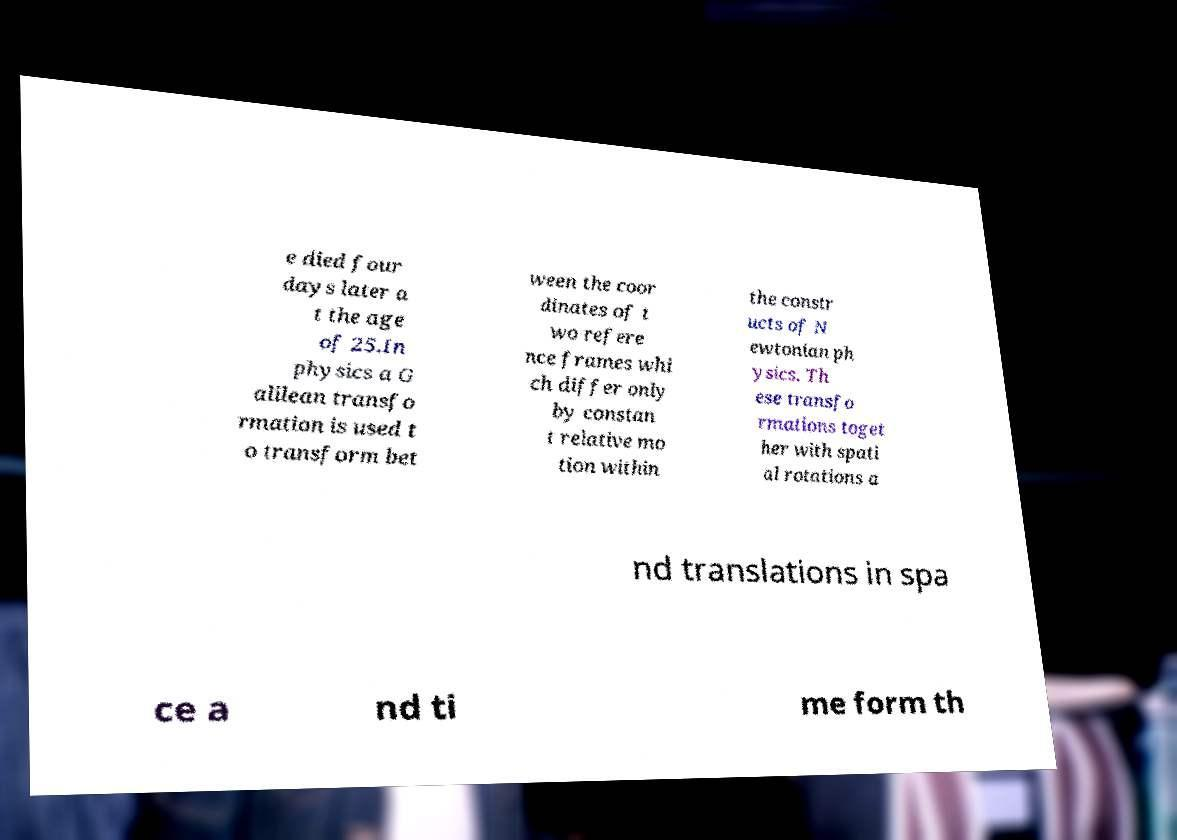I need the written content from this picture converted into text. Can you do that? e died four days later a t the age of 25.In physics a G alilean transfo rmation is used t o transform bet ween the coor dinates of t wo refere nce frames whi ch differ only by constan t relative mo tion within the constr ucts of N ewtonian ph ysics. Th ese transfo rmations toget her with spati al rotations a nd translations in spa ce a nd ti me form th 